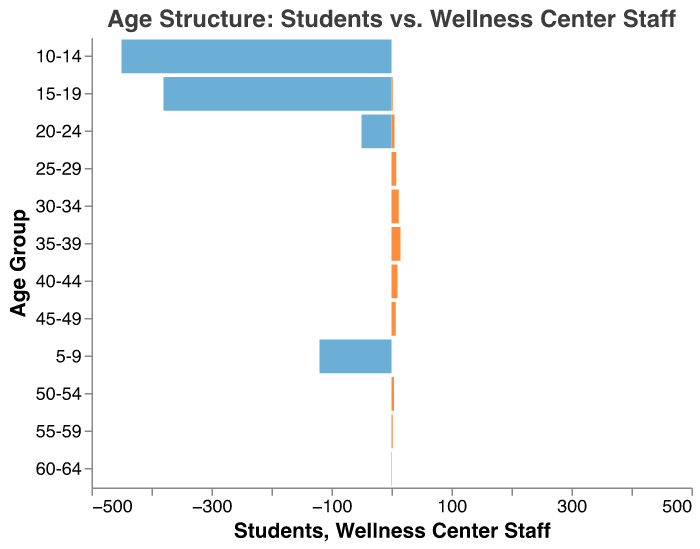What's the title of the figure? The title is usually located at the top of the figure and serves as a summary of the content of the graph. In this case, it is "Age Structure: Students vs. Wellness Center Staff" as stated in the code under the "title" section.
Answer: Age Structure: Students vs. Wellness Center Staff Which age group has the highest number of students? By examining the plot, the age group with the longest bar on the students' side indicates the highest number. The age group 10-14 has the longest bar, which indicates 450 students.
Answer: 10-14 How many wellness center staff members are in the age group 35-39? Referring to the figure, identify the bar corresponding to the age group 35-39 on the wellness center staff side. The bar length shows there are 15 staff members.
Answer: 15 Compare the number of students in the age group 15-19 to the number of wellness center staff in the same age group. Locate the bars for age group 15-19 for both the students and the staff. The students have a count of 380, whereas the staff have a count of 2. Comparing these two values shows that the students are significantly more.
Answer: 380 students and 2 staff Which age group has the smallest number of wellness center staff, and how many are there? To identify this, look for the shortest bar on the wellness center staff side. The age group 60-64 has the smallest count with only 1 staff member.
Answer: 60-64, 1 The sum of students in age groups 5-9 and 10-14 is? Add the number of students in age groups 5-9 and 10-14. From the bars, 120 (5-9) + 450 (10-14) = 570.
Answer: 570 What is the difference in number between the wellness center staff in the age group 20-24 and 25-29? Locate the bars for these age groups. There are 5 staff in the 20-24 age group and 8 in the 25-29 age group. The difference is calculated as 8 - 5 = 3.
Answer: 3 What is the combined total number of wellness center staff in the age groups 30-34 and 35-39? Sum the number of staff in both age groups. From the figure, 12 (30-34) + 15 (35-39) = 27.
Answer: 27 Which has more individuals in the age group 20-24, students, or wellness center staff, and by how much? Compare the bars for the age group 20-24. The students have 50 individuals, and the staff have 5. The difference is calculated as 50 - 5 = 45.
Answer: Students have 45 more In total, how many individuals are represented in the age groups 45-49 and 50-54 for both students and wellness center staff together? Identify the numbers for students and staff in both age groups and sum them. For age group 45-49, there are 0 students and 7 staff; for 50-54, 0 students and 4 staff. Thus, 0 + 7 + 0 + 4 = 11 individuals.
Answer: 11 